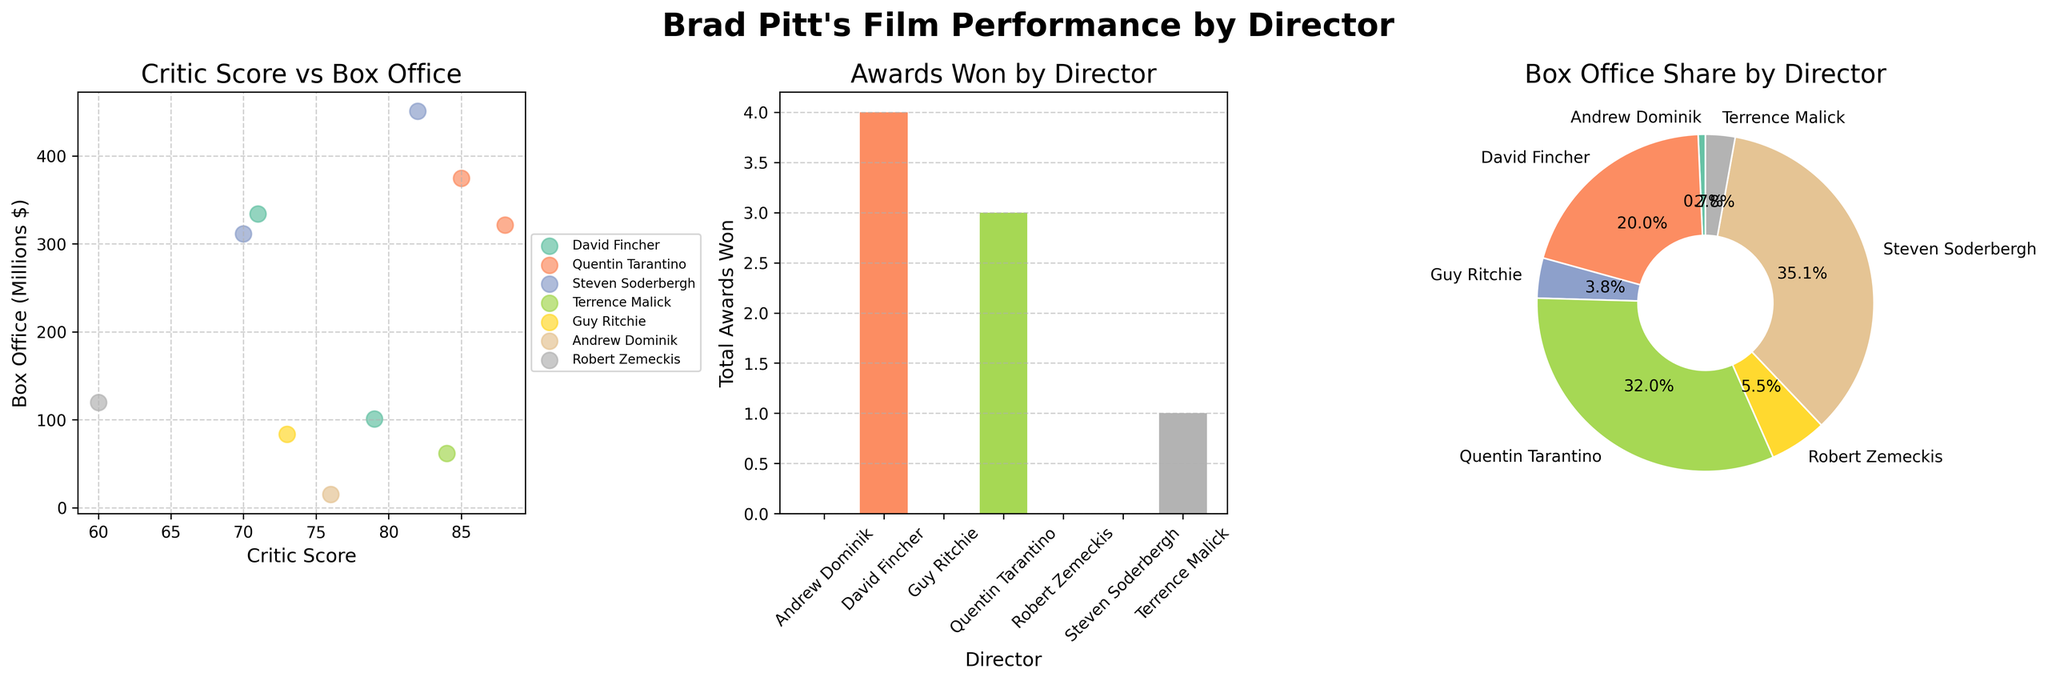Which director's films have the highest overall critic score vs. box office correlation? To answer this, examine the scatter plot in the first subplot. Between two variables: Critic Score and Box Office. Quentin Tarantino makes the most obvious linear pattern representing strong correlation.
Answer: Quentin Tarantino How many total awards have been won by films directed by David Fincher? Look at the bar plot in the second subplot, focusing on the height of the bar corresponding to David Fincher, representing the total awards won.
Answer: 4 Which director has the lowest critic score for one of their films? Examine the scatter plot in the first subplot; find the director with the lowest point on the Critic Score scale. Robert Zemeckis has the lowest with "Allied" at a score of 60.
Answer: Robert Zemeckis Who has contributed the largest share to the overall box office? Look at the pie chart in the third subplot; observe which director's portion of the pie is the largest. Steven Soderbergh’s section is the largest.
Answer: Steven Soderbergh Among the directors featured, which one has the smallest box office earnings for any single film? Check the scatter plot in the first subplot; identify the film by a director situated lowest on the Box Office axis. "The Assassination of Jesse James" by Andrew Dominik has the lowest box office earnings at 15.0 million dollars.
Answer: Andrew Dominik What is the combined box office revenue for films directed by Quentin Tarantino? From the pie chart showing box office share, sum Quentin Tarantino’s values (321.5 for "Inglourious Basterds" and 374.6 for "Once Upon a Time in Hollywood").
Answer: 696.1 million dollars Which director has won the second-highest number of awards? Using the bar plot in the second subplot, observe the second highest bar. Quentin Tarantino's awards bar has the second highest.
Answer: Quentin Tarantino What are the critic scores of the films directed by Terrence Malick? Find Terrence Malick's data points in the scatter plot in the first subplot. He only directed one film "The Tree of Life" with a critic score of 84.
Answer: 84 Which director has films clustered closest together in terms of critic scores? Review the scatter plot in the first subplot to see the spread of Critic Scores across the various directors. Steven Soderbergh has the most closely clustered films with Critic Scores of 70 and 82.
Answer: Steven Soderbergh How many directors have at least one film that earned more than 300 million at the box office? Inspect the scatter plot to count the number of directors with a Box Office earning greater than 300 million. David Fincher, Quentin Tarantino, and Steven Soderbergh achieved this.
Answer: 3 